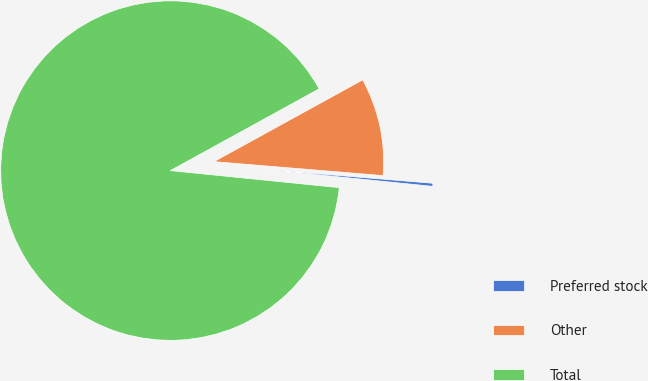Convert chart. <chart><loc_0><loc_0><loc_500><loc_500><pie_chart><fcel>Preferred stock<fcel>Other<fcel>Total<nl><fcel>0.29%<fcel>9.31%<fcel>90.4%<nl></chart> 